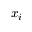<formula> <loc_0><loc_0><loc_500><loc_500>x _ { i }</formula> 